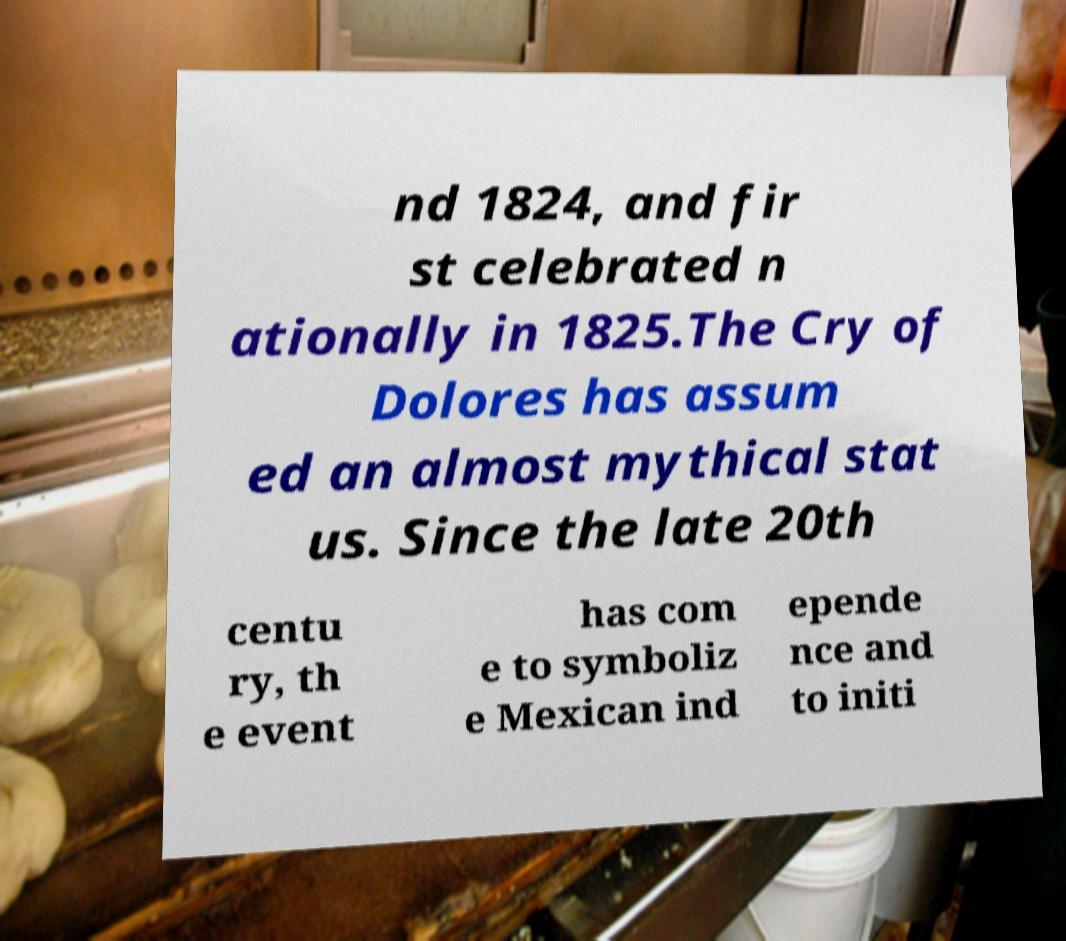Please read and relay the text visible in this image. What does it say? nd 1824, and fir st celebrated n ationally in 1825.The Cry of Dolores has assum ed an almost mythical stat us. Since the late 20th centu ry, th e event has com e to symboliz e Mexican ind epende nce and to initi 